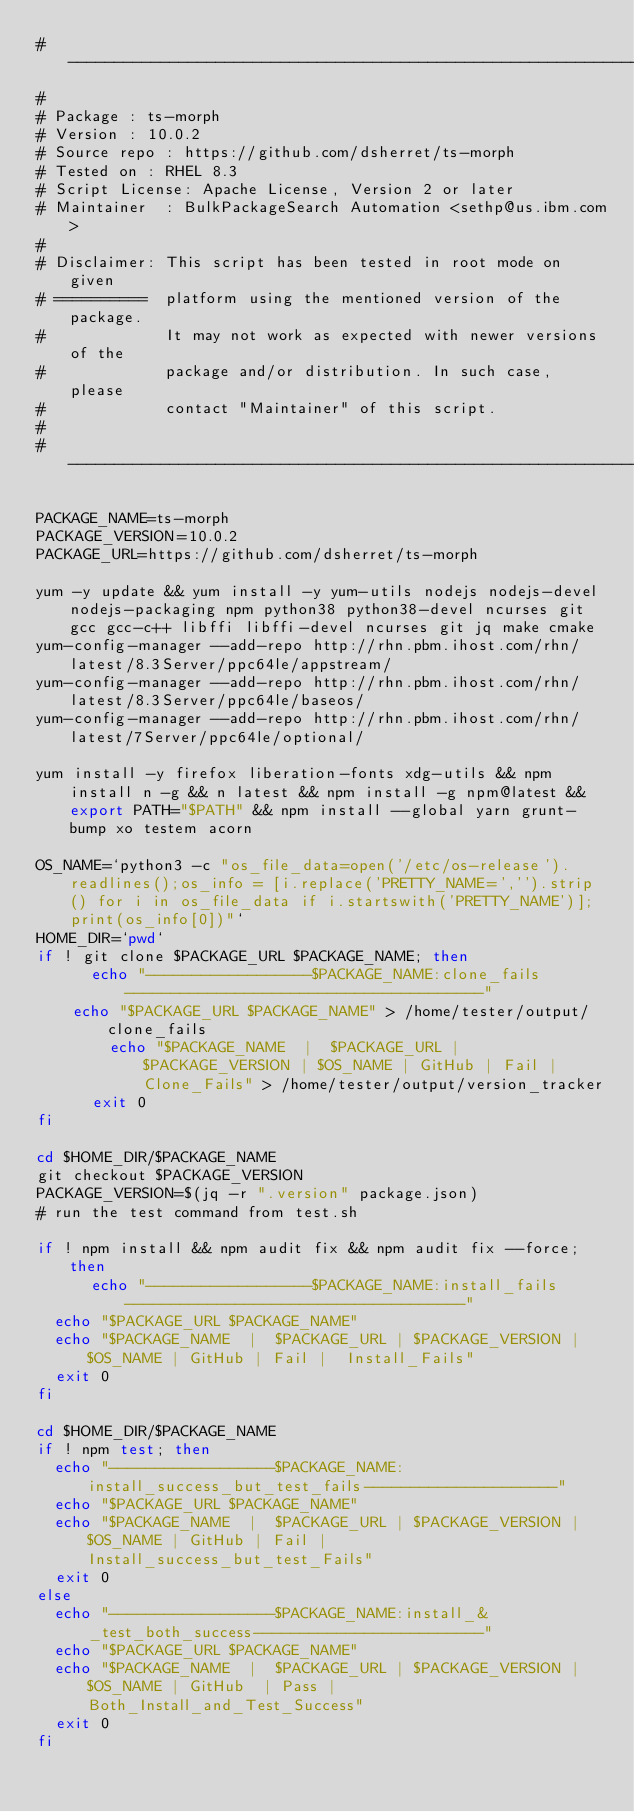Convert code to text. <code><loc_0><loc_0><loc_500><loc_500><_Bash_># -----------------------------------------------------------------------------
#
# Package	: ts-morph
# Version	: 10.0.2
# Source repo	: https://github.com/dsherret/ts-morph
# Tested on	: RHEL 8.3
# Script License: Apache License, Version 2 or later
# Maintainer	: BulkPackageSearch Automation <sethp@us.ibm.com>
#
# Disclaimer: This script has been tested in root mode on given
# ==========  platform using the mentioned version of the package.
#             It may not work as expected with newer versions of the
#             package and/or distribution. In such case, please
#             contact "Maintainer" of this script.
#
# ----------------------------------------------------------------------------

PACKAGE_NAME=ts-morph
PACKAGE_VERSION=10.0.2
PACKAGE_URL=https://github.com/dsherret/ts-morph

yum -y update && yum install -y yum-utils nodejs nodejs-devel nodejs-packaging npm python38 python38-devel ncurses git gcc gcc-c++ libffi libffi-devel ncurses git jq make cmake
yum-config-manager --add-repo http://rhn.pbm.ihost.com/rhn/latest/8.3Server/ppc64le/appstream/
yum-config-manager --add-repo http://rhn.pbm.ihost.com/rhn/latest/8.3Server/ppc64le/baseos/
yum-config-manager --add-repo http://rhn.pbm.ihost.com/rhn/latest/7Server/ppc64le/optional/

yum install -y firefox liberation-fonts xdg-utils && npm install n -g && n latest && npm install -g npm@latest && export PATH="$PATH" && npm install --global yarn grunt-bump xo testem acorn

OS_NAME=`python3 -c "os_file_data=open('/etc/os-release').readlines();os_info = [i.replace('PRETTY_NAME=','').strip() for i in os_file_data if i.startswith('PRETTY_NAME')];print(os_info[0])"`
HOME_DIR=`pwd`
if ! git clone $PACKAGE_URL $PACKAGE_NAME; then
    	echo "------------------$PACKAGE_NAME:clone_fails---------------------------------------"
		echo "$PACKAGE_URL $PACKAGE_NAME" > /home/tester/output/clone_fails
        echo "$PACKAGE_NAME  |  $PACKAGE_URL |  $PACKAGE_VERSION | $OS_NAME | GitHub | Fail |  Clone_Fails" > /home/tester/output/version_tracker
    	exit 0
fi

cd $HOME_DIR/$PACKAGE_NAME
git checkout $PACKAGE_VERSION
PACKAGE_VERSION=$(jq -r ".version" package.json)
# run the test command from test.sh

if ! npm install && npm audit fix && npm audit fix --force; then
     	echo "------------------$PACKAGE_NAME:install_fails-------------------------------------"
	echo "$PACKAGE_URL $PACKAGE_NAME"
	echo "$PACKAGE_NAME  |  $PACKAGE_URL | $PACKAGE_VERSION | $OS_NAME | GitHub | Fail |  Install_Fails"
	exit 0
fi

cd $HOME_DIR/$PACKAGE_NAME
if ! npm test; then
	echo "------------------$PACKAGE_NAME:install_success_but_test_fails---------------------"
	echo "$PACKAGE_URL $PACKAGE_NAME"
	echo "$PACKAGE_NAME  |  $PACKAGE_URL | $PACKAGE_VERSION | $OS_NAME | GitHub | Fail |  Install_success_but_test_Fails"
	exit 0
else
	echo "------------------$PACKAGE_NAME:install_&_test_both_success-------------------------"
	echo "$PACKAGE_URL $PACKAGE_NAME"
	echo "$PACKAGE_NAME  |  $PACKAGE_URL | $PACKAGE_VERSION | $OS_NAME | GitHub  | Pass |  Both_Install_and_Test_Success"
	exit 0
fi</code> 